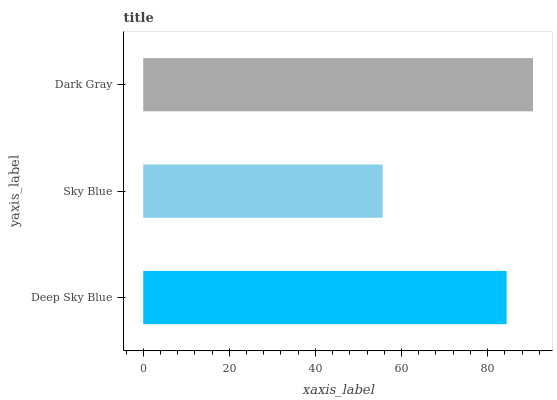Is Sky Blue the minimum?
Answer yes or no. Yes. Is Dark Gray the maximum?
Answer yes or no. Yes. Is Dark Gray the minimum?
Answer yes or no. No. Is Sky Blue the maximum?
Answer yes or no. No. Is Dark Gray greater than Sky Blue?
Answer yes or no. Yes. Is Sky Blue less than Dark Gray?
Answer yes or no. Yes. Is Sky Blue greater than Dark Gray?
Answer yes or no. No. Is Dark Gray less than Sky Blue?
Answer yes or no. No. Is Deep Sky Blue the high median?
Answer yes or no. Yes. Is Deep Sky Blue the low median?
Answer yes or no. Yes. Is Sky Blue the high median?
Answer yes or no. No. Is Sky Blue the low median?
Answer yes or no. No. 